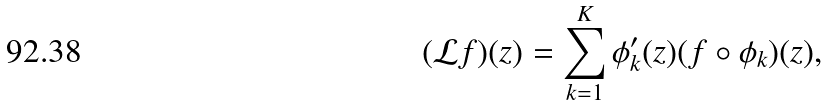Convert formula to latex. <formula><loc_0><loc_0><loc_500><loc_500>( \mathcal { L } f ) ( z ) = \sum _ { k = 1 } ^ { K } \phi ^ { \prime } _ { k } ( z ) ( f \circ \phi _ { k } ) ( z ) ,</formula> 